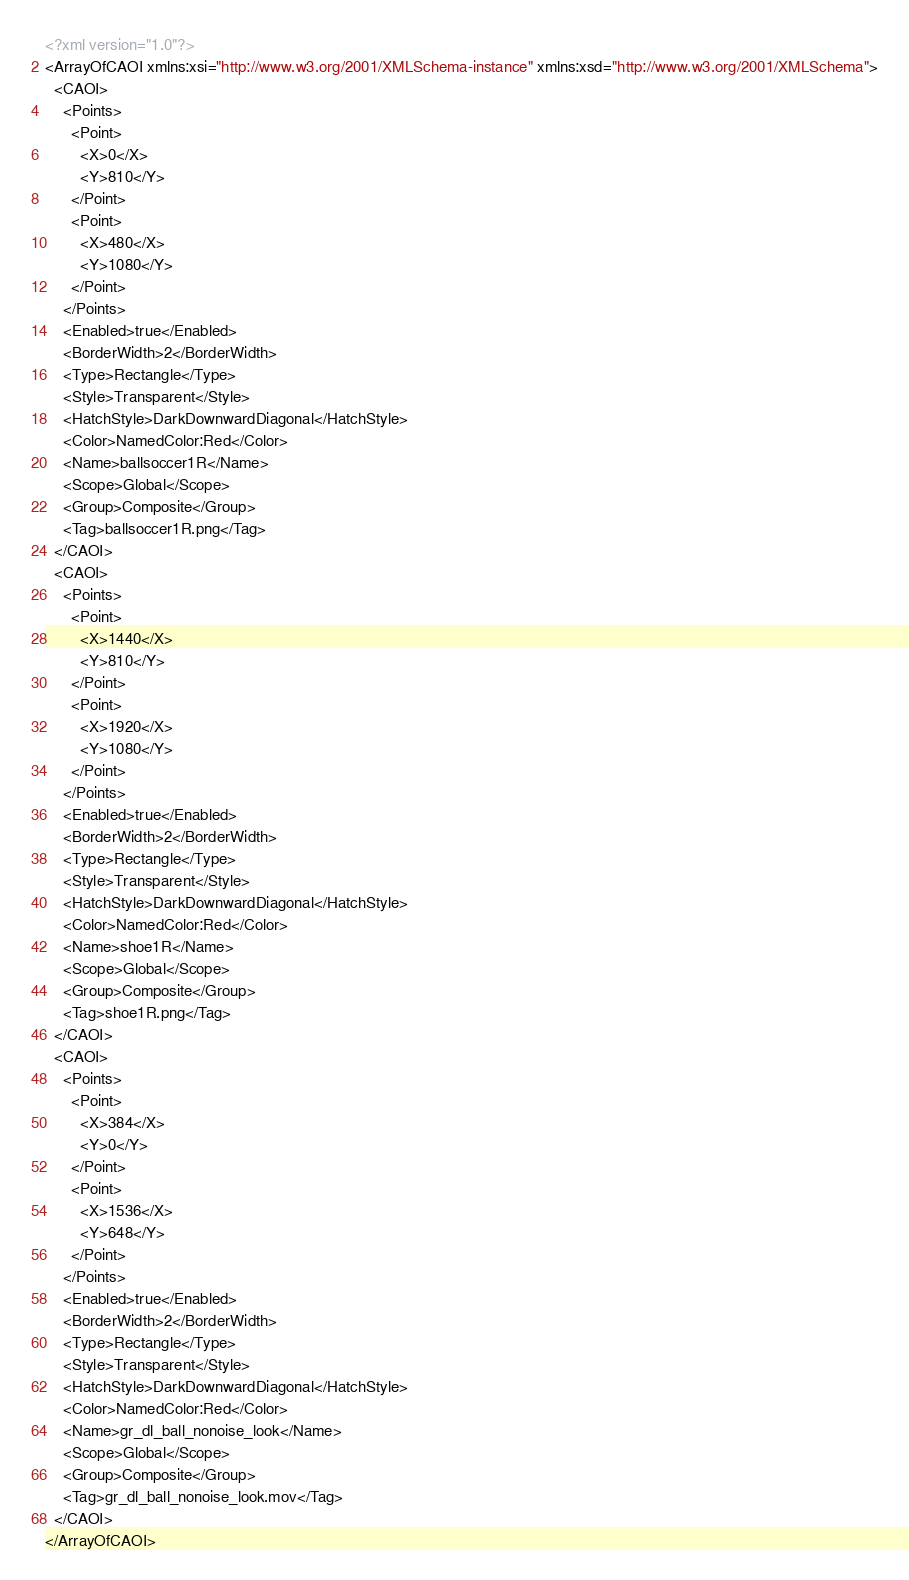Convert code to text. <code><loc_0><loc_0><loc_500><loc_500><_XML_><?xml version="1.0"?>
<ArrayOfCAOI xmlns:xsi="http://www.w3.org/2001/XMLSchema-instance" xmlns:xsd="http://www.w3.org/2001/XMLSchema">
  <CAOI>
    <Points>
      <Point>
        <X>0</X>
        <Y>810</Y>
      </Point>
      <Point>
        <X>480</X>
        <Y>1080</Y>
      </Point>
    </Points>
    <Enabled>true</Enabled>
    <BorderWidth>2</BorderWidth>
    <Type>Rectangle</Type>
    <Style>Transparent</Style>
    <HatchStyle>DarkDownwardDiagonal</HatchStyle>
    <Color>NamedColor:Red</Color>
    <Name>ballsoccer1R</Name>
    <Scope>Global</Scope>
    <Group>Composite</Group>
    <Tag>ballsoccer1R.png</Tag>
  </CAOI>
  <CAOI>
    <Points>
      <Point>
        <X>1440</X>
        <Y>810</Y>
      </Point>
      <Point>
        <X>1920</X>
        <Y>1080</Y>
      </Point>
    </Points>
    <Enabled>true</Enabled>
    <BorderWidth>2</BorderWidth>
    <Type>Rectangle</Type>
    <Style>Transparent</Style>
    <HatchStyle>DarkDownwardDiagonal</HatchStyle>
    <Color>NamedColor:Red</Color>
    <Name>shoe1R</Name>
    <Scope>Global</Scope>
    <Group>Composite</Group>
    <Tag>shoe1R.png</Tag>
  </CAOI>
  <CAOI>
    <Points>
      <Point>
        <X>384</X>
        <Y>0</Y>
      </Point>
      <Point>
        <X>1536</X>
        <Y>648</Y>
      </Point>
    </Points>
    <Enabled>true</Enabled>
    <BorderWidth>2</BorderWidth>
    <Type>Rectangle</Type>
    <Style>Transparent</Style>
    <HatchStyle>DarkDownwardDiagonal</HatchStyle>
    <Color>NamedColor:Red</Color>
    <Name>gr_dl_ball_nonoise_look</Name>
    <Scope>Global</Scope>
    <Group>Composite</Group>
    <Tag>gr_dl_ball_nonoise_look.mov</Tag>
  </CAOI>
</ArrayOfCAOI></code> 